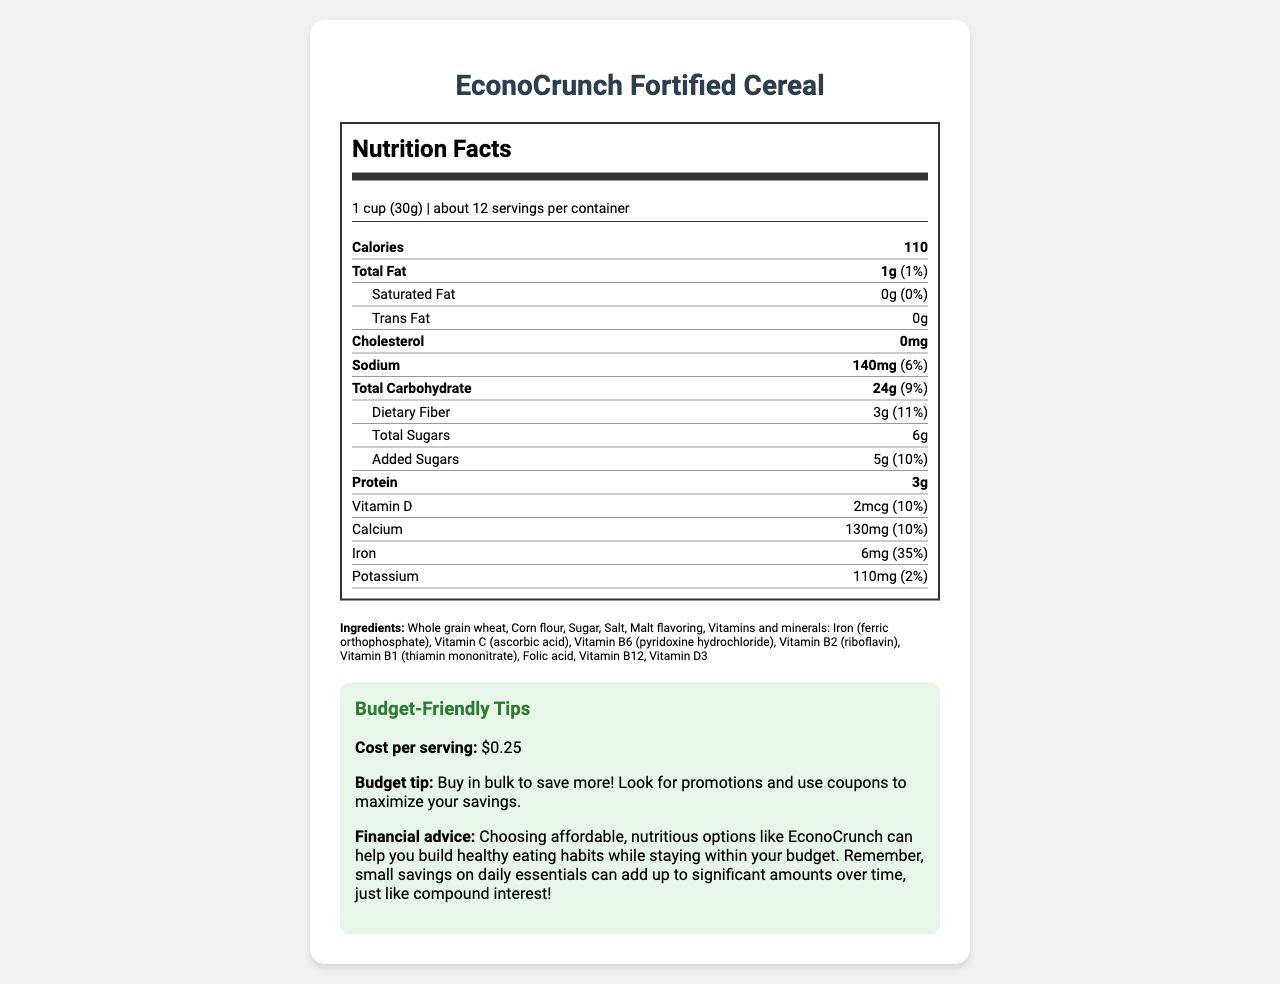What is the serving size of EconoCrunch Fortified Cereal? The serving size is clearly mentioned in the nutrition label as "1 cup (30g)".
Answer: 1 cup (30g) How many calories are in one serving of this cereal? The calories per serving are listed right under the nutrition facts title as 110.
Answer: 110 calories What percentage of the Daily Value for iron does one serving provide? The Daily Value percentage for iron is stated as 35% on the nutritional label.
Answer: 35% Does the cereal contain any dietary fiber? If so, how much? The cereal contains dietary fiber, as indicated by the label listing 3g of dietary fiber with an 11% daily value.
Answer: Yes, 3g What is the cost per serving for EconoCrunch Fortified Cereal? The cost per serving is mentioned in the budget-friendly tips section as $0.25.
Answer: $0.25 Which company manufactures EconoCrunch Fortified Cereal?
A. Delicious Foods Corp.
B. Budget Foods Inc.
C. HealthNut Enterprises The manufacturer information provided states Budget Foods Inc. manufactures this cereal.
Answer: B How many servings are there per container? The label states that there are about 12 servings per container.
Answer: About 12 Does the cereal contain any trans fat? It is clearly stated in the nutrition label that the cereal contains 0g of trans fat.
Answer: No On a regular budget, what purchasing advice is given for maximum savings? The budget tip recommends buying in bulk and using promotions and coupons to maximize savings.
Answer: Buy in bulk to save more and use promotions and coupons Does the product contain any allergens? The allergy information states that it contains wheat and may contain traces of soy.
Answer: Yes Describe the main idea of the document. The document is an informative label that serves to both inform about the nutritional content and provide financial advice on making economical choices, especially for young adults on a budget.
Answer: The document provides the nutritional information of EconoCrunch Fortified Cereal, highlighting it as a cost-effective breakfast option that is rich in essential vitamins and minerals. It also includes budget-friendly tips and financial advice for making smart purchasing decisions. Is the cholesterol content in EconoCrunch Fortified Cereal higher than the sodium content? The cereal contains 0mg of cholesterol and 140mg of sodium, so the sodium content is higher.
Answer: No How much Vitamin C is in one serving, and what percentage of the daily value does it represent? The label states that there are 9mg of Vitamin C per serving, which is 10% of the daily value.
Answer: 9mg, 10% What are the instructions for storage? The storage instructions are to keep the cereal in a cool, dry place and to seal the package tightly after opening.
Answer: Store in a cool, dry place. Seal package tightly after opening. How many grams of sugar are added to the cereal? The label indicates that there are 5g of added sugars in the cereal.
Answer: 5g How is the cereal described in terms of its target audience and purpose? The product description highlights it as a smart choice for young adults who want to maintain healthy eating habits within a budget.
Answer: EconoCrunch Fortified Cereal is described as a nutritious and affordable breakfast option aimed at young adults on a budget, offering essential vitamins and minerals. What is the expiration date of the cereal? The document advises checking the "Best if used by" date on the package for the expiration date, which is not directly provided.
Answer: Cannot be determined Does the cereal contain any Vitamin D3?
A. Yes, 2mcg
B. No Vitamin D3
C. Yes, 9mg The label states that the cereal contains Vitamin D3 at 2mcg per serving.
Answer: A 